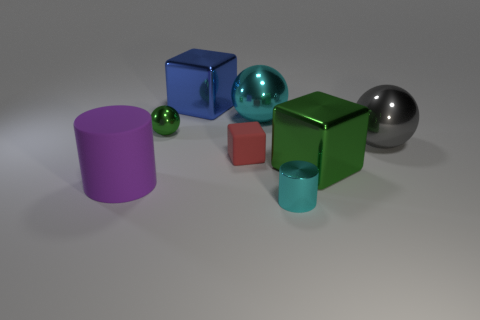Subtract all big metal spheres. How many spheres are left? 1 Add 2 large green metal cubes. How many objects exist? 10 Subtract all blocks. How many objects are left? 5 Subtract all large shiny cylinders. Subtract all red things. How many objects are left? 7 Add 2 small rubber blocks. How many small rubber blocks are left? 3 Add 4 large gray shiny balls. How many large gray shiny balls exist? 5 Subtract 0 red spheres. How many objects are left? 8 